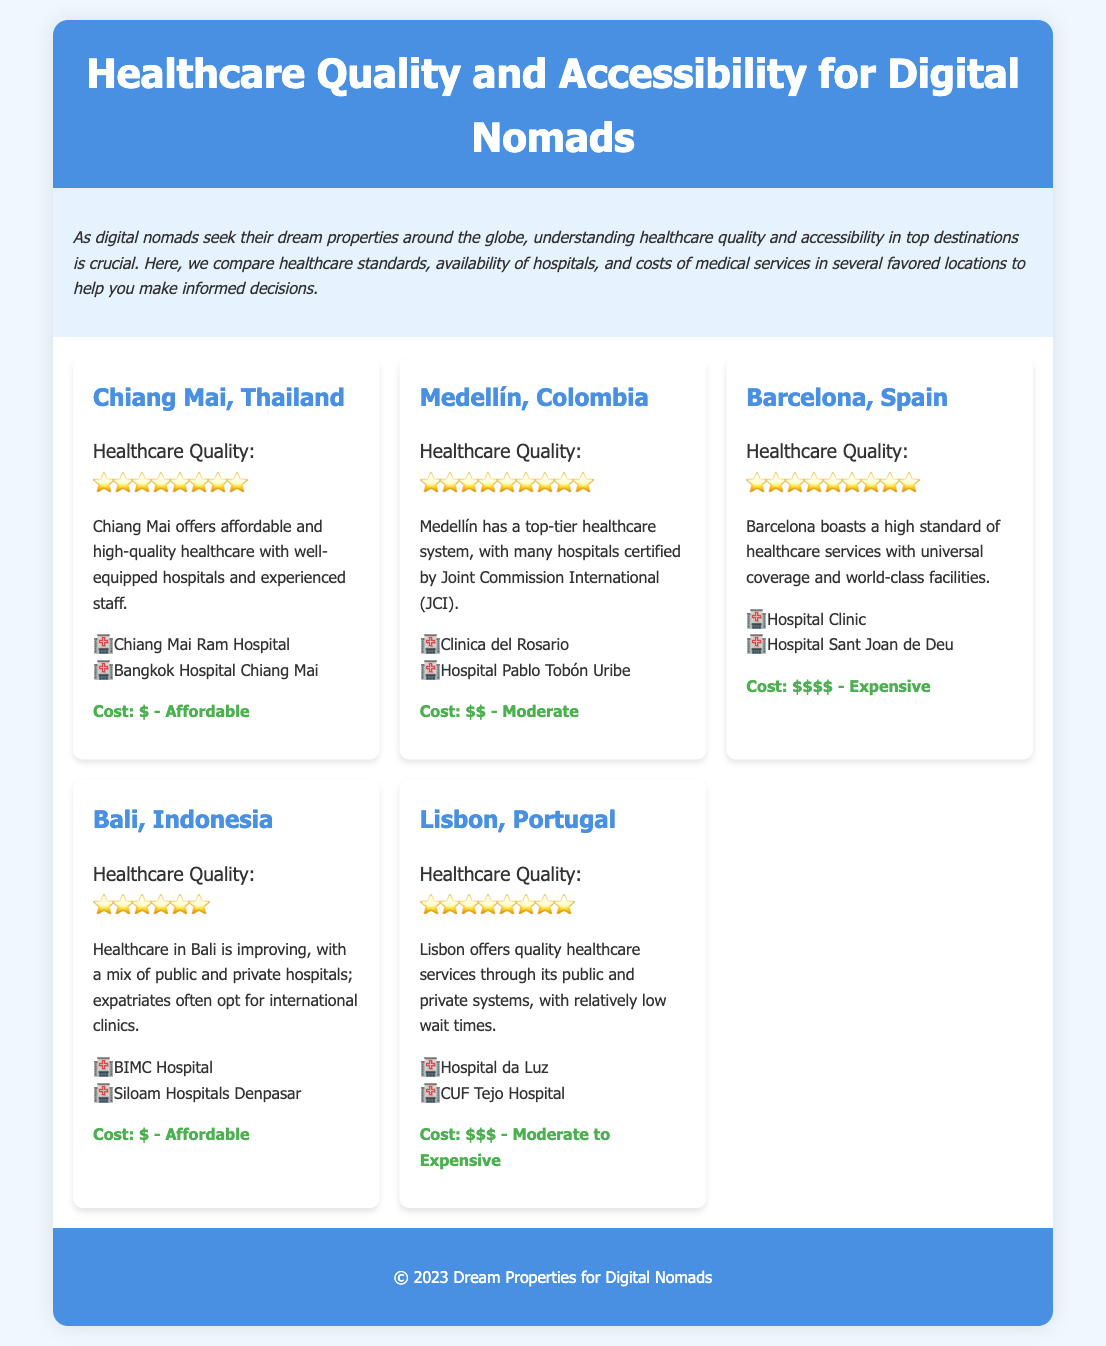What is the healthcare quality rating for Chiang Mai? The healthcare quality rating for Chiang Mai is listed as ⭐️⭐️⭐️⭐️⭐️⭐️⭐️⭐️.
Answer: ⭐️⭐️⭐️⭐️⭐️⭐️⭐️⭐️ How many hospitals are listed for Medellín, Colombia? The document lists two hospitals for Medellín, Colombia: Clinica del Rosario and Hospital Pablo Tobón Uribe.
Answer: 2 What is the cost of healthcare in Barcelona? The document states that the cost of healthcare in Barcelona is $$$$ - Expensive.
Answer: $$$$ Which destination has the highest healthcare quality rating? Medellín, Colombia has the highest healthcare quality rating with ⭐️⭐️⭐️⭐️⭐️⭐️⭐️⭐️⭐️.
Answer: ⭐️⭐️⭐️⭐️⭐️⭐️⭐️⭐️⭐️ How many hospitals are listed under Bali, Indonesia? The hospitals listed for Bali, Indonesia are BIMC Hospital and Siloam Hospitals Denpasar, totaling two.
Answer: 2 Which destination offers affordable healthcare? Chiang Mai, Thailand is noted for its affordable healthcare.
Answer: Chiang Mai, Thailand What is the healthcare quality rating for Lisbon? The healthcare quality rating for Lisbon is ⭐️⭐️⭐️⭐️⭐️⭐️⭐️⭐️.
Answer: ⭐️⭐️⭐️⭐️⭐️⭐️⭐️⭐️ What is the cost category of healthcare in Medellín? The cost category of healthcare in Medellín is $$ - Moderate.
Answer: $$ - Moderate Which two hospitals are listed for Barcelona? The document lists Hospital Clinic and Hospital Sant Joan de Deu for Barcelona.
Answer: Hospital Clinic, Hospital Sant Joan de Deu 